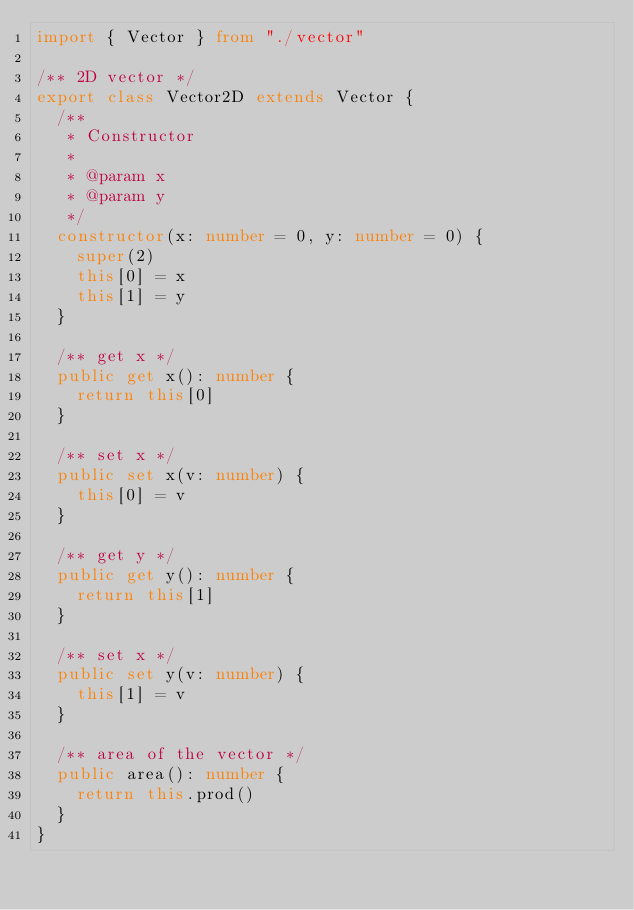Convert code to text. <code><loc_0><loc_0><loc_500><loc_500><_TypeScript_>import { Vector } from "./vector"

/** 2D vector */
export class Vector2D extends Vector {
  /**
   * Constructor
   *
   * @param x
   * @param y
   */
  constructor(x: number = 0, y: number = 0) {
    super(2)
    this[0] = x
    this[1] = y
  }

  /** get x */
  public get x(): number {
    return this[0]
  }

  /** set x */
  public set x(v: number) {
    this[0] = v
  }

  /** get y */
  public get y(): number {
    return this[1]
  }

  /** set x */
  public set y(v: number) {
    this[1] = v
  }

  /** area of the vector */
  public area(): number {
    return this.prod()
  }
}
</code> 